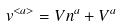Convert formula to latex. <formula><loc_0><loc_0><loc_500><loc_500>v ^ { < a > } = V n ^ { a } + V ^ { a }</formula> 